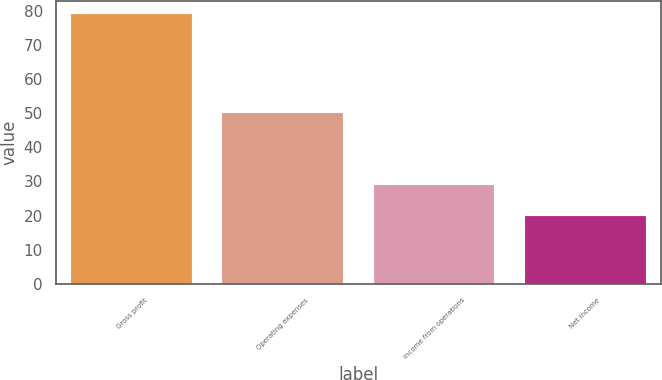<chart> <loc_0><loc_0><loc_500><loc_500><bar_chart><fcel>Gross profit<fcel>Operating expenses<fcel>Income from operations<fcel>Net income<nl><fcel>79<fcel>50<fcel>29<fcel>20<nl></chart> 